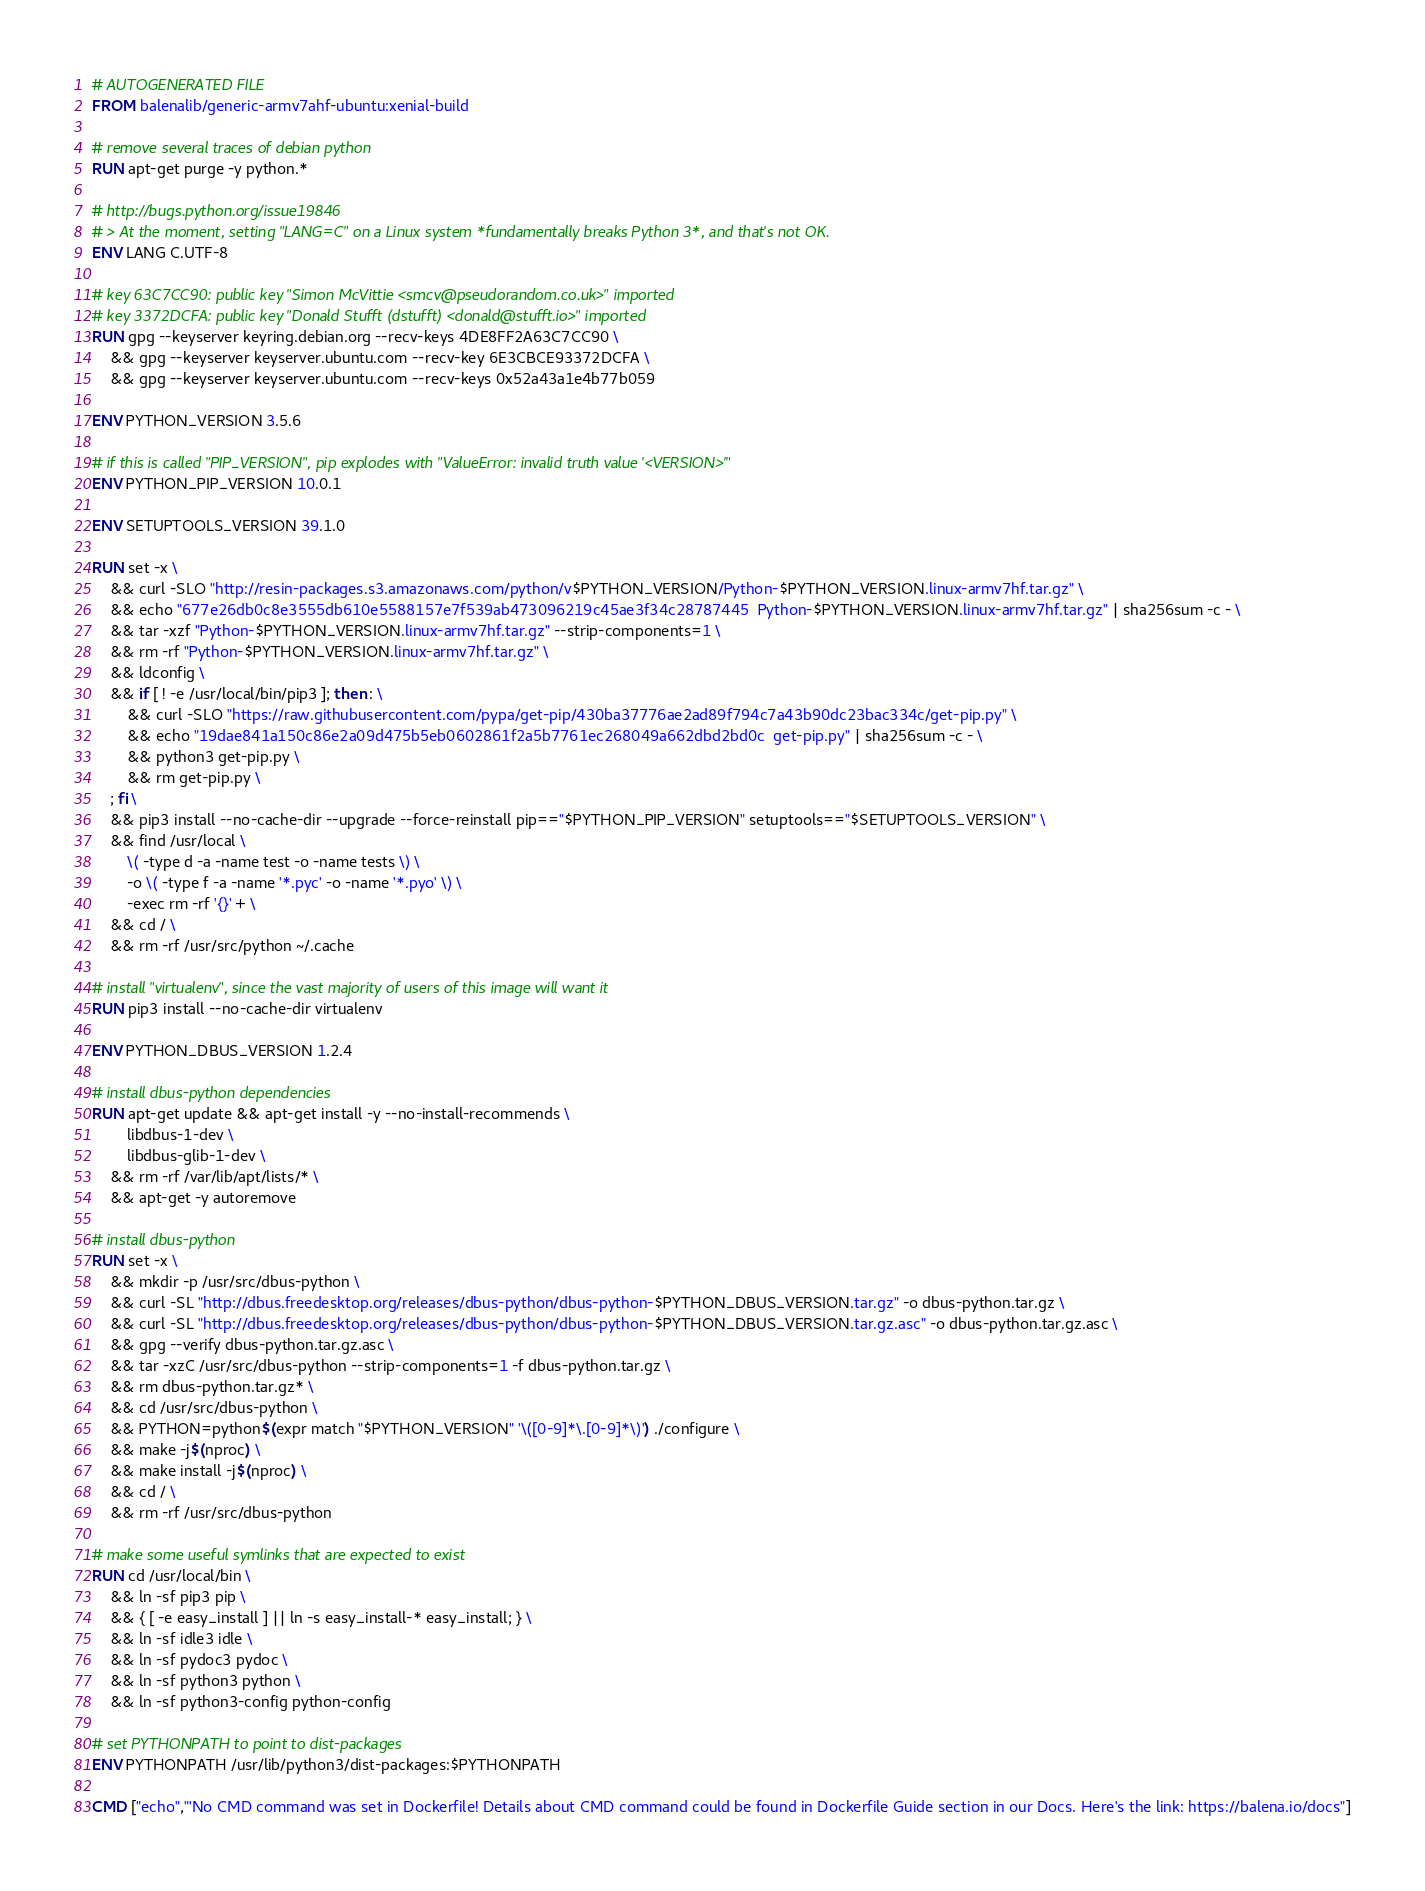Convert code to text. <code><loc_0><loc_0><loc_500><loc_500><_Dockerfile_># AUTOGENERATED FILE
FROM balenalib/generic-armv7ahf-ubuntu:xenial-build

# remove several traces of debian python
RUN apt-get purge -y python.*

# http://bugs.python.org/issue19846
# > At the moment, setting "LANG=C" on a Linux system *fundamentally breaks Python 3*, and that's not OK.
ENV LANG C.UTF-8

# key 63C7CC90: public key "Simon McVittie <smcv@pseudorandom.co.uk>" imported
# key 3372DCFA: public key "Donald Stufft (dstufft) <donald@stufft.io>" imported
RUN gpg --keyserver keyring.debian.org --recv-keys 4DE8FF2A63C7CC90 \
	&& gpg --keyserver keyserver.ubuntu.com --recv-key 6E3CBCE93372DCFA \
	&& gpg --keyserver keyserver.ubuntu.com --recv-keys 0x52a43a1e4b77b059

ENV PYTHON_VERSION 3.5.6

# if this is called "PIP_VERSION", pip explodes with "ValueError: invalid truth value '<VERSION>'"
ENV PYTHON_PIP_VERSION 10.0.1

ENV SETUPTOOLS_VERSION 39.1.0

RUN set -x \
	&& curl -SLO "http://resin-packages.s3.amazonaws.com/python/v$PYTHON_VERSION/Python-$PYTHON_VERSION.linux-armv7hf.tar.gz" \
	&& echo "677e26db0c8e3555db610e5588157e7f539ab473096219c45ae3f34c28787445  Python-$PYTHON_VERSION.linux-armv7hf.tar.gz" | sha256sum -c - \
	&& tar -xzf "Python-$PYTHON_VERSION.linux-armv7hf.tar.gz" --strip-components=1 \
	&& rm -rf "Python-$PYTHON_VERSION.linux-armv7hf.tar.gz" \
	&& ldconfig \
	&& if [ ! -e /usr/local/bin/pip3 ]; then : \
		&& curl -SLO "https://raw.githubusercontent.com/pypa/get-pip/430ba37776ae2ad89f794c7a43b90dc23bac334c/get-pip.py" \
		&& echo "19dae841a150c86e2a09d475b5eb0602861f2a5b7761ec268049a662dbd2bd0c  get-pip.py" | sha256sum -c - \
		&& python3 get-pip.py \
		&& rm get-pip.py \
	; fi \
	&& pip3 install --no-cache-dir --upgrade --force-reinstall pip=="$PYTHON_PIP_VERSION" setuptools=="$SETUPTOOLS_VERSION" \
	&& find /usr/local \
		\( -type d -a -name test -o -name tests \) \
		-o \( -type f -a -name '*.pyc' -o -name '*.pyo' \) \
		-exec rm -rf '{}' + \
	&& cd / \
	&& rm -rf /usr/src/python ~/.cache

# install "virtualenv", since the vast majority of users of this image will want it
RUN pip3 install --no-cache-dir virtualenv

ENV PYTHON_DBUS_VERSION 1.2.4

# install dbus-python dependencies 
RUN apt-get update && apt-get install -y --no-install-recommends \
		libdbus-1-dev \
		libdbus-glib-1-dev \
	&& rm -rf /var/lib/apt/lists/* \
	&& apt-get -y autoremove

# install dbus-python
RUN set -x \
	&& mkdir -p /usr/src/dbus-python \
	&& curl -SL "http://dbus.freedesktop.org/releases/dbus-python/dbus-python-$PYTHON_DBUS_VERSION.tar.gz" -o dbus-python.tar.gz \
	&& curl -SL "http://dbus.freedesktop.org/releases/dbus-python/dbus-python-$PYTHON_DBUS_VERSION.tar.gz.asc" -o dbus-python.tar.gz.asc \
	&& gpg --verify dbus-python.tar.gz.asc \
	&& tar -xzC /usr/src/dbus-python --strip-components=1 -f dbus-python.tar.gz \
	&& rm dbus-python.tar.gz* \
	&& cd /usr/src/dbus-python \
	&& PYTHON=python$(expr match "$PYTHON_VERSION" '\([0-9]*\.[0-9]*\)') ./configure \
	&& make -j$(nproc) \
	&& make install -j$(nproc) \
	&& cd / \
	&& rm -rf /usr/src/dbus-python

# make some useful symlinks that are expected to exist
RUN cd /usr/local/bin \
	&& ln -sf pip3 pip \
	&& { [ -e easy_install ] || ln -s easy_install-* easy_install; } \
	&& ln -sf idle3 idle \
	&& ln -sf pydoc3 pydoc \
	&& ln -sf python3 python \
	&& ln -sf python3-config python-config

# set PYTHONPATH to point to dist-packages
ENV PYTHONPATH /usr/lib/python3/dist-packages:$PYTHONPATH

CMD ["echo","'No CMD command was set in Dockerfile! Details about CMD command could be found in Dockerfile Guide section in our Docs. Here's the link: https://balena.io/docs"]</code> 